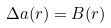Convert formula to latex. <formula><loc_0><loc_0><loc_500><loc_500>\Delta a ( r ) = B ( r )</formula> 